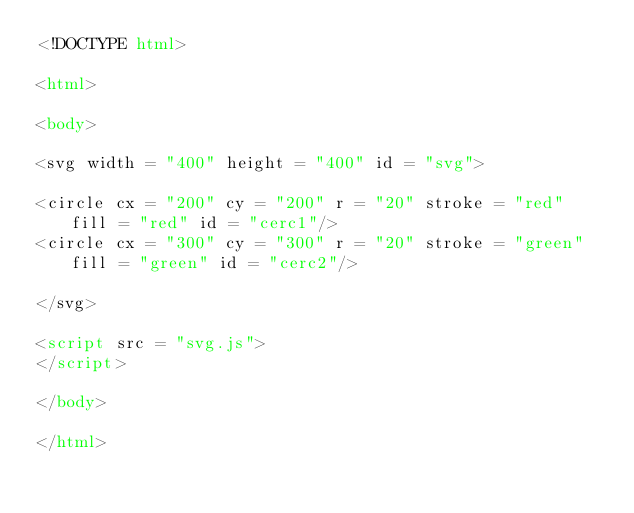<code> <loc_0><loc_0><loc_500><loc_500><_HTML_><!DOCTYPE html>

<html>

<body>

<svg width = "400" height = "400" id = "svg">

<circle cx = "200" cy = "200" r = "20" stroke = "red" fill = "red" id = "cerc1"/>
<circle cx = "300" cy = "300" r = "20" stroke = "green" fill = "green" id = "cerc2"/>

</svg>

<script src = "svg.js">
</script>

</body>

</html></code> 